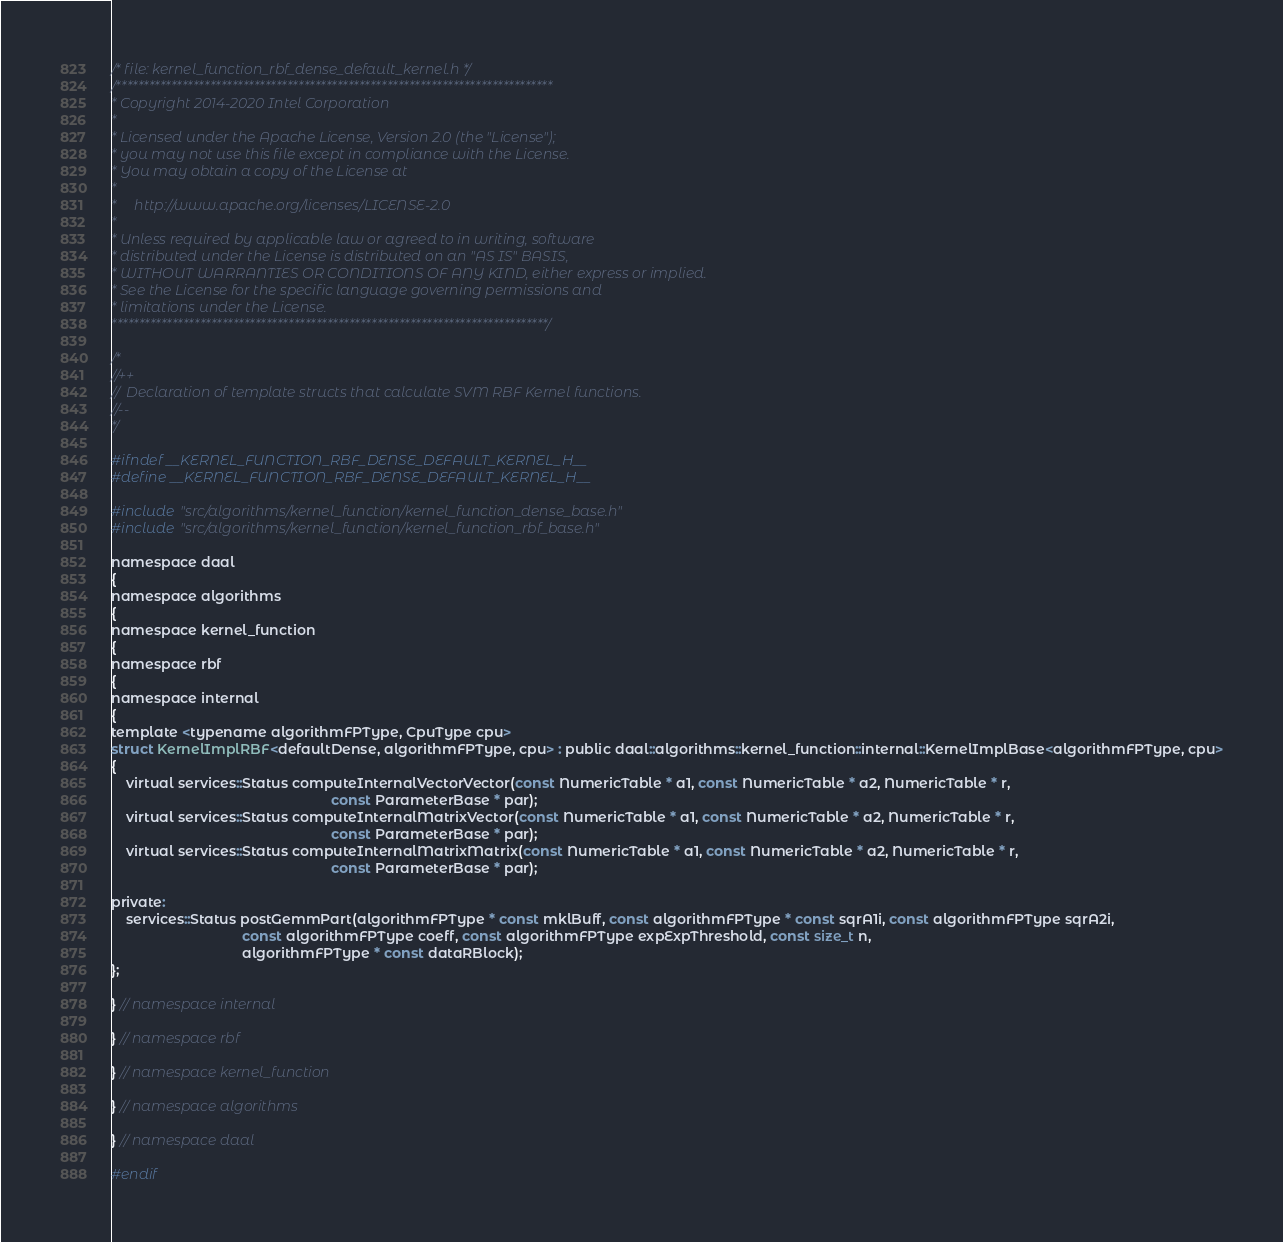Convert code to text. <code><loc_0><loc_0><loc_500><loc_500><_C_>/* file: kernel_function_rbf_dense_default_kernel.h */
/*******************************************************************************
* Copyright 2014-2020 Intel Corporation
*
* Licensed under the Apache License, Version 2.0 (the "License");
* you may not use this file except in compliance with the License.
* You may obtain a copy of the License at
*
*     http://www.apache.org/licenses/LICENSE-2.0
*
* Unless required by applicable law or agreed to in writing, software
* distributed under the License is distributed on an "AS IS" BASIS,
* WITHOUT WARRANTIES OR CONDITIONS OF ANY KIND, either express or implied.
* See the License for the specific language governing permissions and
* limitations under the License.
*******************************************************************************/

/*
//++
//  Declaration of template structs that calculate SVM RBF Kernel functions.
//--
*/

#ifndef __KERNEL_FUNCTION_RBF_DENSE_DEFAULT_KERNEL_H__
#define __KERNEL_FUNCTION_RBF_DENSE_DEFAULT_KERNEL_H__

#include "src/algorithms/kernel_function/kernel_function_dense_base.h"
#include "src/algorithms/kernel_function/kernel_function_rbf_base.h"

namespace daal
{
namespace algorithms
{
namespace kernel_function
{
namespace rbf
{
namespace internal
{
template <typename algorithmFPType, CpuType cpu>
struct KernelImplRBF<defaultDense, algorithmFPType, cpu> : public daal::algorithms::kernel_function::internal::KernelImplBase<algorithmFPType, cpu>
{
    virtual services::Status computeInternalVectorVector(const NumericTable * a1, const NumericTable * a2, NumericTable * r,
                                                         const ParameterBase * par);
    virtual services::Status computeInternalMatrixVector(const NumericTable * a1, const NumericTable * a2, NumericTable * r,
                                                         const ParameterBase * par);
    virtual services::Status computeInternalMatrixMatrix(const NumericTable * a1, const NumericTable * a2, NumericTable * r,
                                                         const ParameterBase * par);

private:
    services::Status postGemmPart(algorithmFPType * const mklBuff, const algorithmFPType * const sqrA1i, const algorithmFPType sqrA2i,
                                  const algorithmFPType coeff, const algorithmFPType expExpThreshold, const size_t n,
                                  algorithmFPType * const dataRBlock);
};

} // namespace internal

} // namespace rbf

} // namespace kernel_function

} // namespace algorithms

} // namespace daal

#endif
</code> 